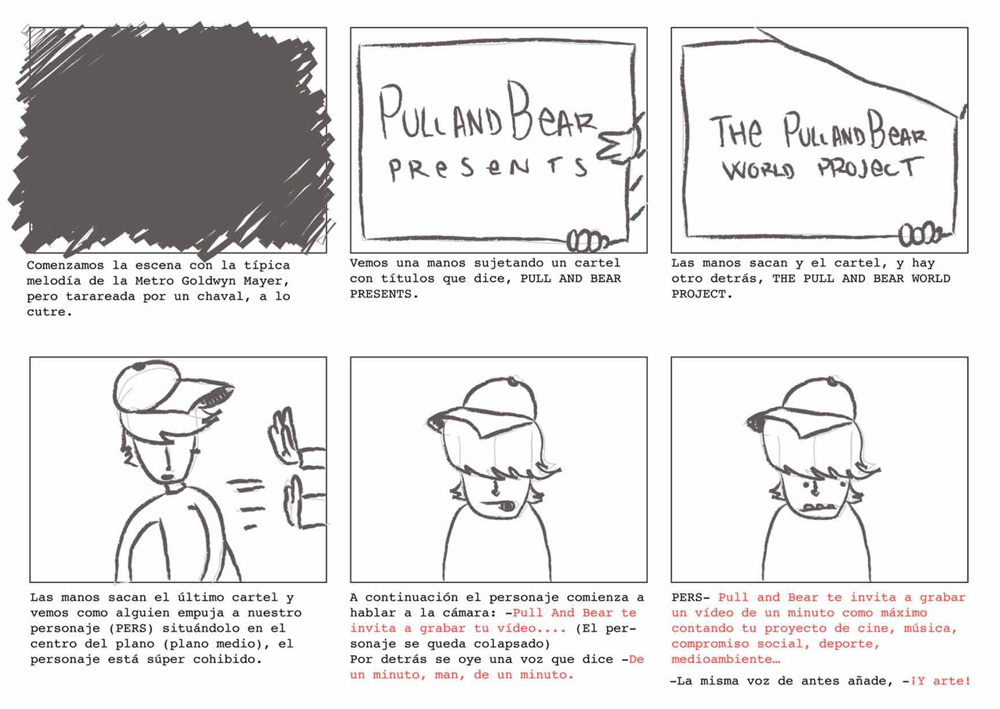What is the emotional expression of the character when he is finally revealed in the comic strip, and what might this suggest about his attitude towards the project he is presenting? The character's emotional expression when revealed is one of shyness and modesty, as indicated by his slightly blushing cheeks and downcast eyes. This could suggest that he feels somewhat hesitant or bashful about being the center of attention or about the significance of the project he is presenting. Despite this, his participation and the act of inviting others to join in the project indicate a level of commitment and a desire to engage the audience, even if he personally feels a bit reserved about his role. 